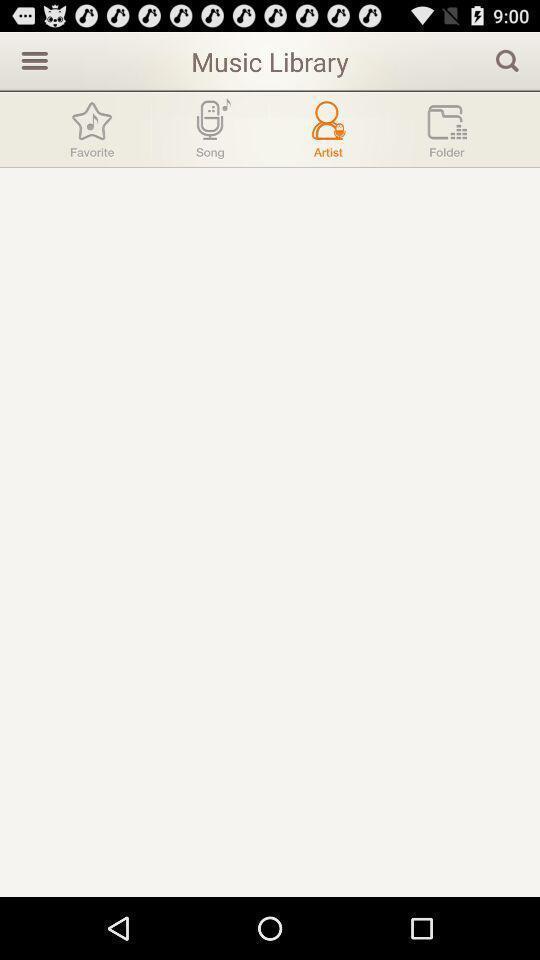Summarize the information in this screenshot. Screen showing music library. 